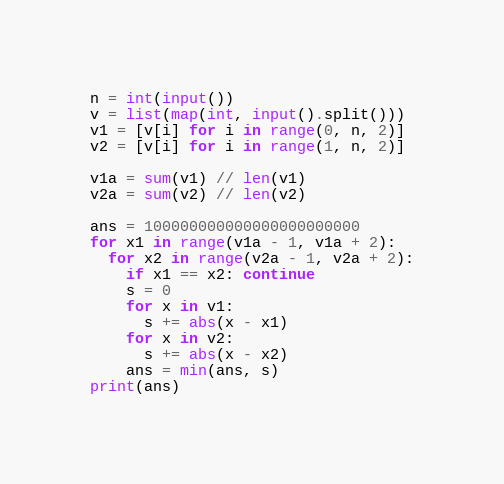<code> <loc_0><loc_0><loc_500><loc_500><_Python_>n = int(input())
v = list(map(int, input().split()))
v1 = [v[i] for i in range(0, n, 2)]
v2 = [v[i] for i in range(1, n, 2)]

v1a = sum(v1) // len(v1)
v2a = sum(v2) // len(v2)

ans = 100000000000000000000000
for x1 in range(v1a - 1, v1a + 2):
  for x2 in range(v2a - 1, v2a + 2):
    if x1 == x2: continue
    s = 0
    for x in v1:
      s += abs(x - x1)
    for x in v2:
      s += abs(x - x2)
    ans = min(ans, s)
print(ans)</code> 